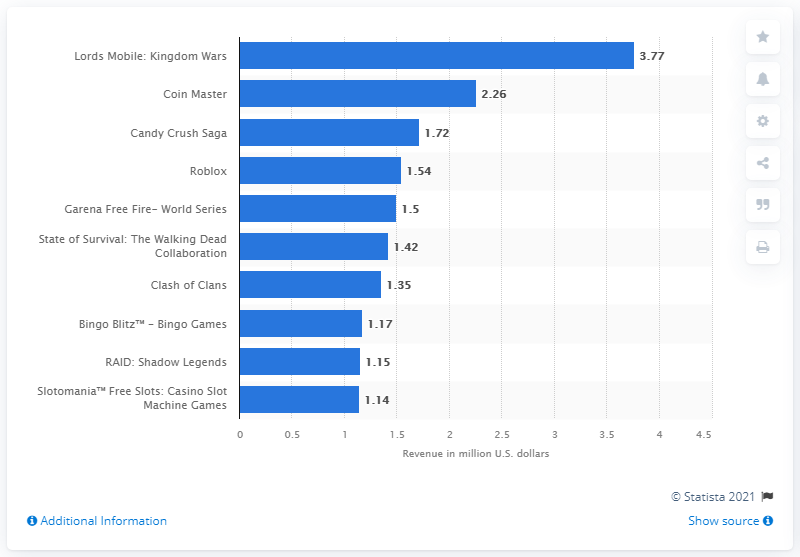Give some essential details in this illustration. In April 2021, the top-grossing Android app in the Google Play Store in the United States was Lords Mobile: Kingdom Wars. Coin Master was the second most popular app in the United States. 